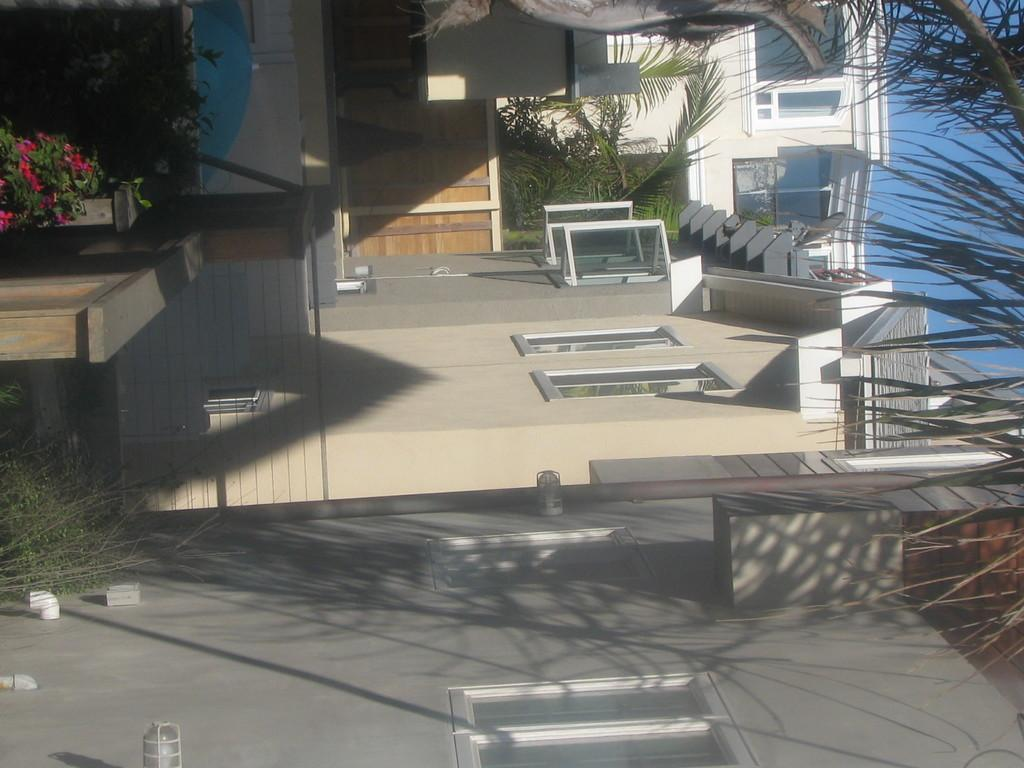What type of structures can be seen in the image? There are houses in the image. How are the houses arranged? The houses are arranged in a row. Can you describe the state of any specific house? The windows of one house are open. What other natural elements can be seen in the image? There are trees in the image. How are the trees described? The trees are described as beautiful. What type of coal is being used to fuel the afterthought in the image? There is no mention of coal or an afterthought in the image; it features houses and trees. Are there any bears visible in the image? There are no bears present in the image. 